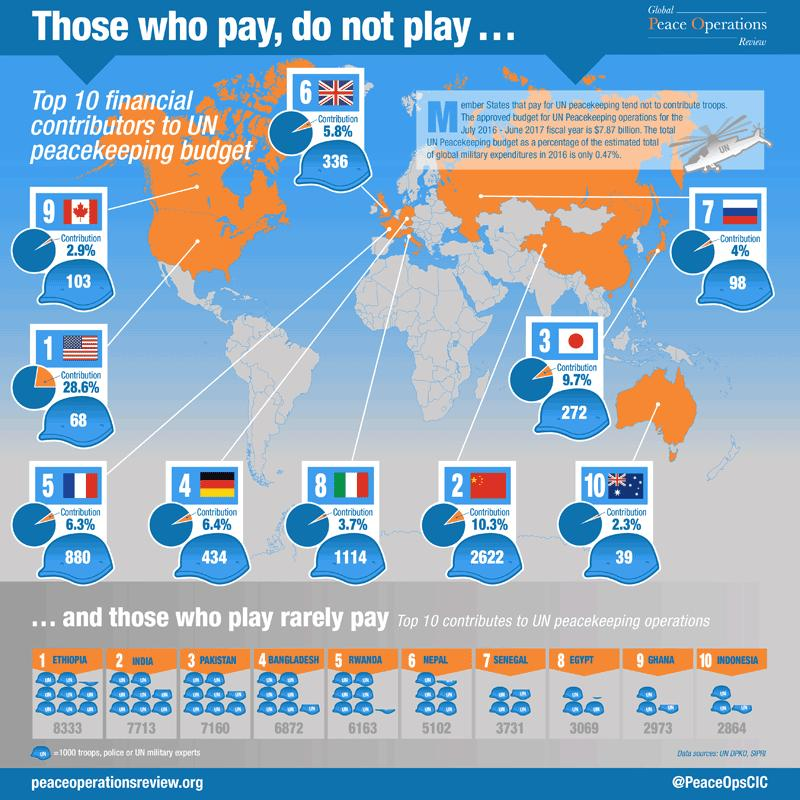Indicate a few pertinent items in this graphic. Japan and the UK contribute a significantly smaller percentage to the UN peacekeeping budget compared to other countries. The second highest contribution of troops to UN peacekeeping operations is 7,713. The United States has contributed a significant number of troops to the United Nations peacekeeping efforts, with a current total of 68 troops as of today. Australia is the lowest contributor of troops and funds among all countries. Pakistan contributes significantly fewer troops to UN peacekeeping operations than Bangladesh, with a current difference of 288 troops. 